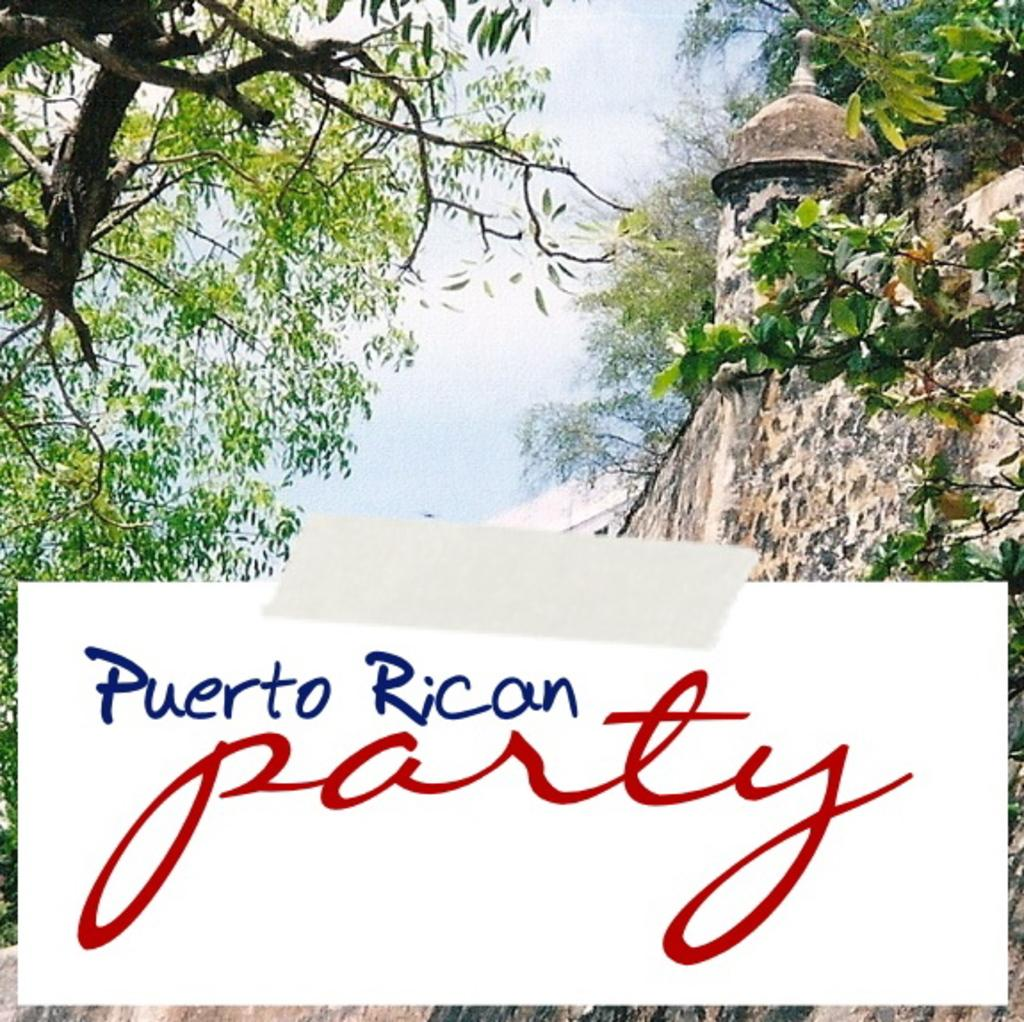What is on the card that is visible in the image? There is a card with text in the image. What can be seen in the background of the image? There is a building and a group of trees in the background of the image. What is visible above the building and trees in the image? The sky is visible in the background of the image. How does the card perform magic tricks in the image? The card does not perform magic tricks in the image; it is simply a card with text. 